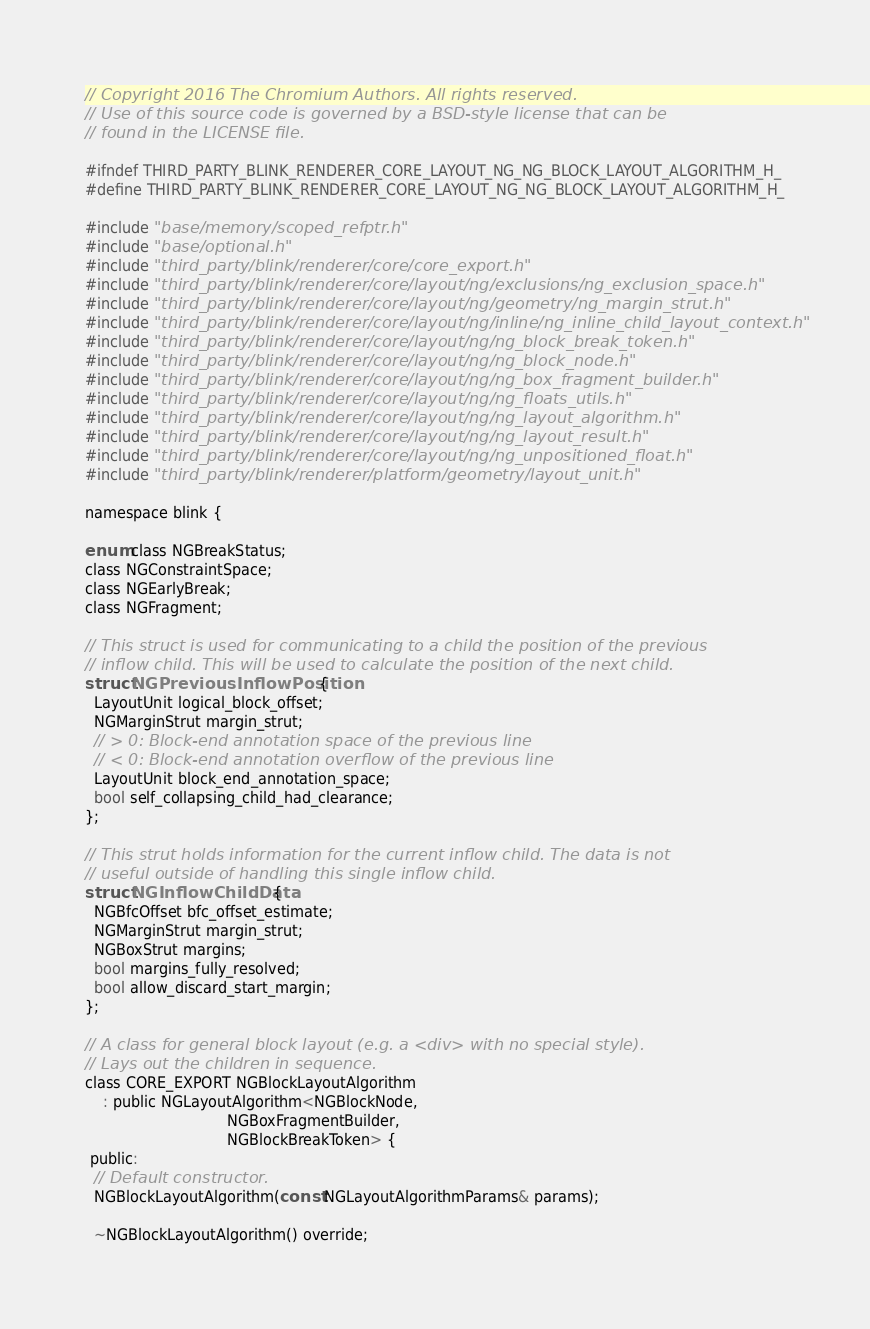Convert code to text. <code><loc_0><loc_0><loc_500><loc_500><_C_>// Copyright 2016 The Chromium Authors. All rights reserved.
// Use of this source code is governed by a BSD-style license that can be
// found in the LICENSE file.

#ifndef THIRD_PARTY_BLINK_RENDERER_CORE_LAYOUT_NG_NG_BLOCK_LAYOUT_ALGORITHM_H_
#define THIRD_PARTY_BLINK_RENDERER_CORE_LAYOUT_NG_NG_BLOCK_LAYOUT_ALGORITHM_H_

#include "base/memory/scoped_refptr.h"
#include "base/optional.h"
#include "third_party/blink/renderer/core/core_export.h"
#include "third_party/blink/renderer/core/layout/ng/exclusions/ng_exclusion_space.h"
#include "third_party/blink/renderer/core/layout/ng/geometry/ng_margin_strut.h"
#include "third_party/blink/renderer/core/layout/ng/inline/ng_inline_child_layout_context.h"
#include "third_party/blink/renderer/core/layout/ng/ng_block_break_token.h"
#include "third_party/blink/renderer/core/layout/ng/ng_block_node.h"
#include "third_party/blink/renderer/core/layout/ng/ng_box_fragment_builder.h"
#include "third_party/blink/renderer/core/layout/ng/ng_floats_utils.h"
#include "third_party/blink/renderer/core/layout/ng/ng_layout_algorithm.h"
#include "third_party/blink/renderer/core/layout/ng/ng_layout_result.h"
#include "third_party/blink/renderer/core/layout/ng/ng_unpositioned_float.h"
#include "third_party/blink/renderer/platform/geometry/layout_unit.h"

namespace blink {

enum class NGBreakStatus;
class NGConstraintSpace;
class NGEarlyBreak;
class NGFragment;

// This struct is used for communicating to a child the position of the previous
// inflow child. This will be used to calculate the position of the next child.
struct NGPreviousInflowPosition {
  LayoutUnit logical_block_offset;
  NGMarginStrut margin_strut;
  // > 0: Block-end annotation space of the previous line
  // < 0: Block-end annotation overflow of the previous line
  LayoutUnit block_end_annotation_space;
  bool self_collapsing_child_had_clearance;
};

// This strut holds information for the current inflow child. The data is not
// useful outside of handling this single inflow child.
struct NGInflowChildData {
  NGBfcOffset bfc_offset_estimate;
  NGMarginStrut margin_strut;
  NGBoxStrut margins;
  bool margins_fully_resolved;
  bool allow_discard_start_margin;
};

// A class for general block layout (e.g. a <div> with no special style).
// Lays out the children in sequence.
class CORE_EXPORT NGBlockLayoutAlgorithm
    : public NGLayoutAlgorithm<NGBlockNode,
                               NGBoxFragmentBuilder,
                               NGBlockBreakToken> {
 public:
  // Default constructor.
  NGBlockLayoutAlgorithm(const NGLayoutAlgorithmParams& params);

  ~NGBlockLayoutAlgorithm() override;
</code> 